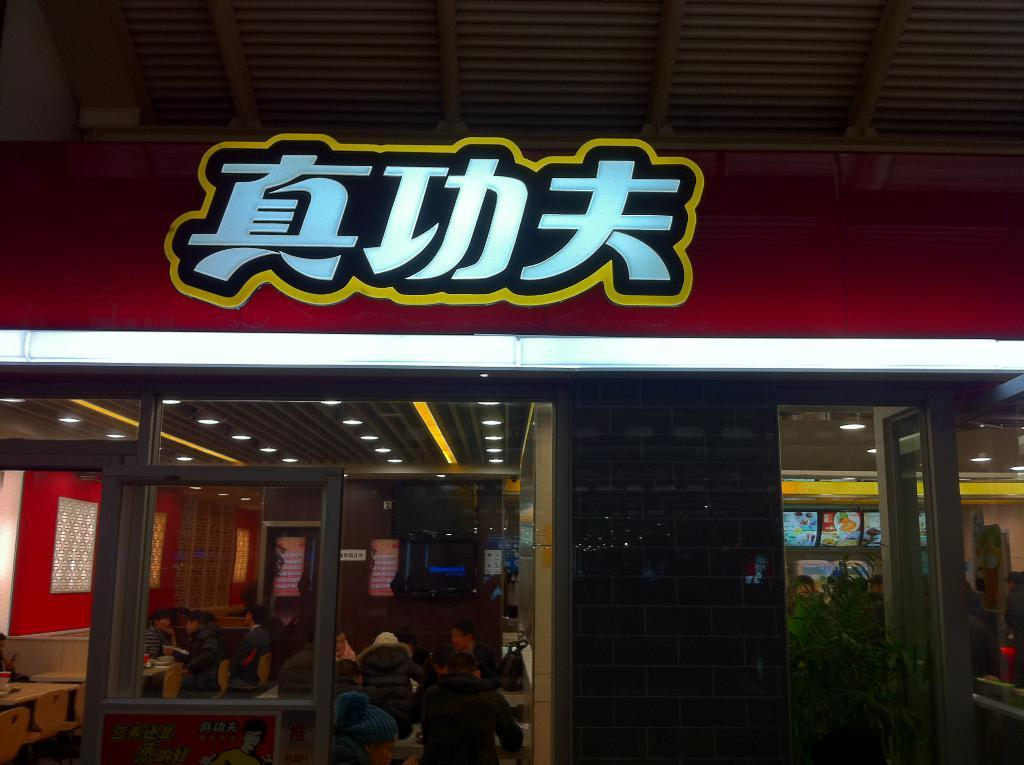What type of structure is visible in the image? There is a house in the image. What is attached to the house? There is a board on the house. Where are the people located in the image? The people are sitting inside the house. What are the people sitting beside in the image? The people are sitting beside tables. What type of lighting is visible in the image? There are ceiling lights visible in the image. What part of the house is visible in the image? The roof of the house is visible. What type of vegetation is present in the image? There is a plant in the image. How long does it take for the island to appear in the image? There is no island present in the image. What type of minute hand can be seen on the clock in the image? There is no clock visible in the image. 